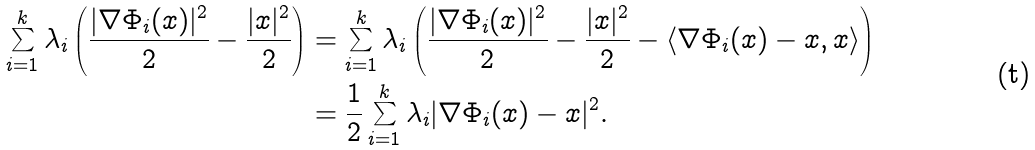Convert formula to latex. <formula><loc_0><loc_0><loc_500><loc_500>\sum _ { i = 1 } ^ { k } \lambda _ { i } \left ( \frac { | \nabla \Phi _ { i } ( x ) | ^ { 2 } } { 2 } - \frac { | x | ^ { 2 } } { 2 } \right ) & = \sum _ { i = 1 } ^ { k } \lambda _ { i } \left ( \frac { | \nabla \Phi _ { i } ( x ) | ^ { 2 } } { 2 } - \frac { | x | ^ { 2 } } { 2 } - \langle \nabla \Phi _ { i } ( x ) - x , x \rangle \right ) \\ & = \frac { 1 } { 2 } \sum _ { i = 1 } ^ { k } \lambda _ { i } | \nabla \Phi _ { i } ( x ) - x | ^ { 2 } .</formula> 